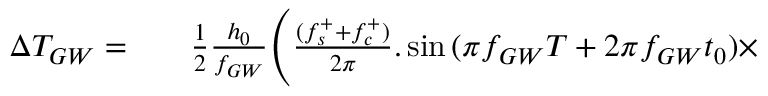Convert formula to latex. <formula><loc_0><loc_0><loc_500><loc_500>\begin{array} { r l r } { \Delta T _ { G W } = } & { \frac { 1 } { 2 } \frac { h _ { 0 } } { f _ { G W } } \Big ( \frac { ( f _ { s } ^ { + } + f _ { c } ^ { + } ) } { 2 \pi } . \sin { ( \pi f _ { G W } T + 2 \pi f _ { G W } t _ { 0 } ) } \times } \end{array}</formula> 